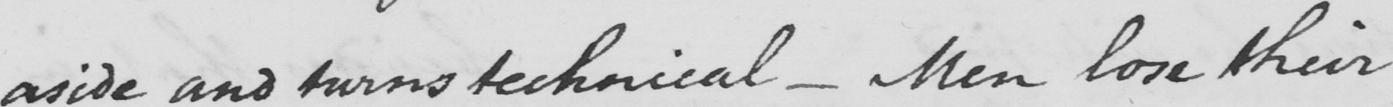What is written in this line of handwriting? aside and turns technical  _  Men lose their 